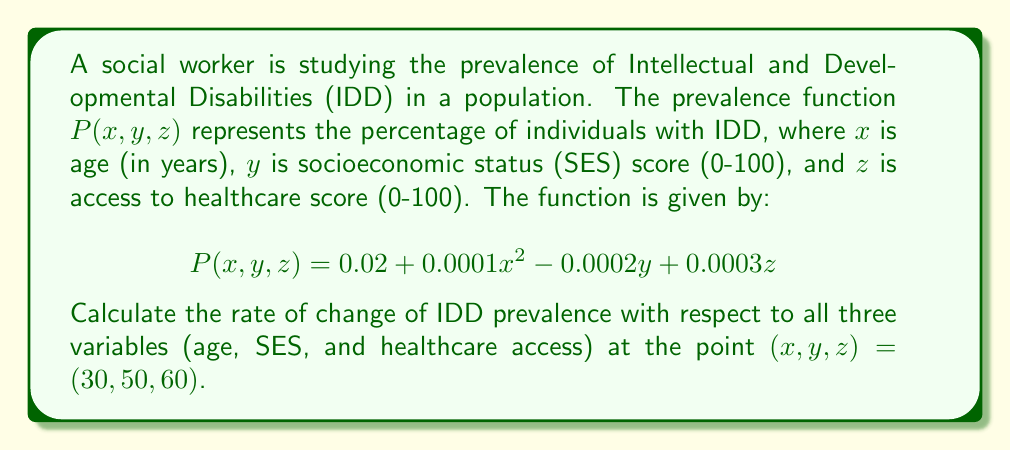Can you answer this question? To find the rate of change of IDD prevalence with respect to all three variables, we need to calculate the gradient of the function $P(x,y,z)$ at the given point. The gradient is a vector of partial derivatives with respect to each variable.

Step 1: Calculate the partial derivatives.

$\frac{\partial P}{\partial x} = 0.0002x$
$\frac{\partial P}{\partial y} = -0.0002$
$\frac{\partial P}{\partial z} = 0.0003$

Step 2: Evaluate the partial derivatives at the point $(30, 50, 60)$.

$\frac{\partial P}{\partial x}|_{(30,50,60)} = 0.0002(30) = 0.006$
$\frac{\partial P}{\partial y}|_{(30,50,60)} = -0.0002$
$\frac{\partial P}{\partial z}|_{(30,50,60)} = 0.0003$

Step 3: Form the gradient vector.

The gradient vector at $(30, 50, 60)$ is:

$$\nabla P(30,50,60) = \left\langle 0.006, -0.0002, 0.0003 \right\rangle$$

This vector represents the rate of change of IDD prevalence with respect to age, SES, and healthcare access at the given point.
Answer: $\nabla P(30,50,60) = \left\langle 0.006, -0.0002, 0.0003 \right\rangle$ 